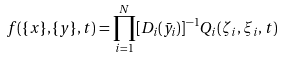Convert formula to latex. <formula><loc_0><loc_0><loc_500><loc_500>f ( \{ x \} , \{ y \} , t ) = { \prod _ { i = 1 } ^ { N } [ D _ { i } ( \bar { y _ { i } } ) ] ^ { - 1 } } Q _ { i } ( \zeta _ { i } , \xi _ { i } , t )</formula> 